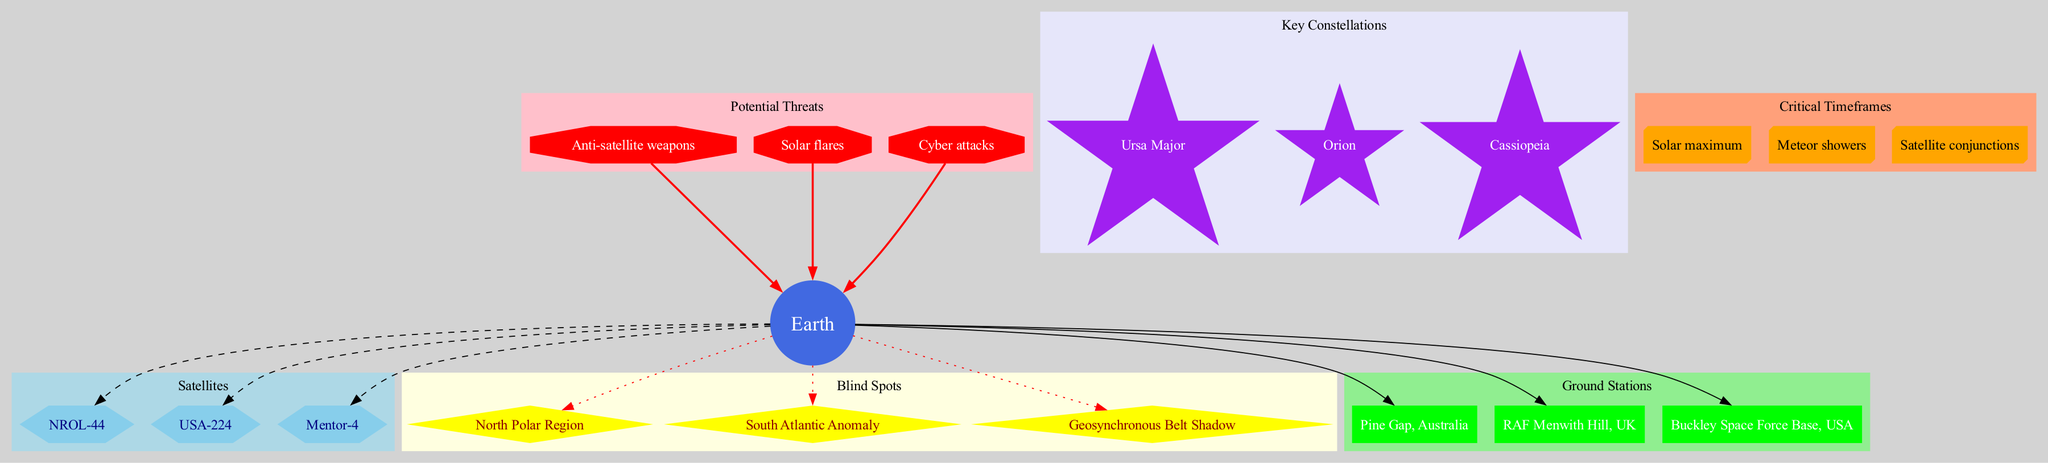What is the central object in the diagram? The diagram indicates that "Earth" is the central object since it is represented as the primary node from which all other nodes originate.
Answer: Earth How many satellites are depicted in the diagram? The diagram includes three satellites named NROL-44, USA-224, and Mentor-4. Counting these gives a total of three.
Answer: 3 Which blind spot is located in the northern hemisphere? The "North Polar Region" is identified as a specific blind spot located in the northern hemisphere, as indicated by its labeling in the diagram.
Answer: North Polar Region What shape represents ground stations in the diagram? Ground stations are represented as boxes, which can be confirmed by observing their shape in the cluster of ground stations.
Answer: Box How many potential threats are mentioned in the diagram? The diagram outlines three potential threats: Anti-satellite weapons, Solar flares, and Cyber attacks. By counting these, we determine there are three threats listed.
Answer: 3 Which constellation is depicted as a key one in the diagram? The constellation "Orion" is highlighted as a key constellation, based on its distinctive representation among the key constellations shown in the diagram.
Answer: Orion Which critical timeframe is depicted as associated with solar activity? "Solar maximum" is identified as a critical timeframe related to solar activity, as it specifically refers to periods of heightened solar phenomena.
Answer: Solar maximum What type of node connects potential threats to Earth? The potential threats are depicted as octagons connecting to Earth with bold red edges, indicating the severity of these threats towards the central object.
Answer: Octagon Which blind spot is located above the equator? The "North Polar Region" is the only blind spot located above the equator since other listed blind spots are either in the Southern Hemisphere or specifically refer to the geosynchronous area.
Answer: North Polar Region 